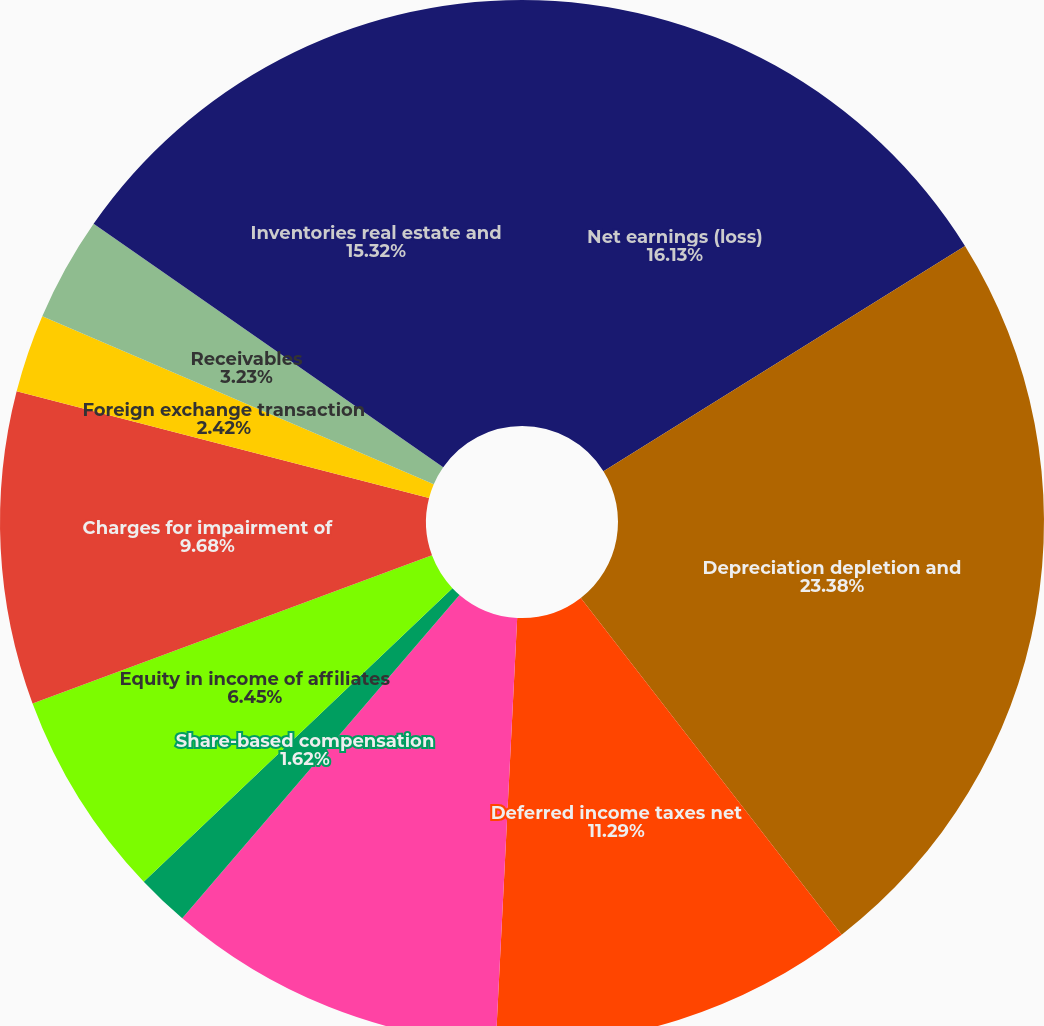Convert chart. <chart><loc_0><loc_0><loc_500><loc_500><pie_chart><fcel>Net earnings (loss)<fcel>Depreciation depletion and<fcel>Deferred income taxes net<fcel>Pension and other<fcel>Share-based compensation<fcel>Equity in income of affiliates<fcel>Charges for impairment of<fcel>Foreign exchange transaction<fcel>Receivables<fcel>Inventories real estate and<nl><fcel>16.13%<fcel>23.38%<fcel>11.29%<fcel>10.48%<fcel>1.62%<fcel>6.45%<fcel>9.68%<fcel>2.42%<fcel>3.23%<fcel>15.32%<nl></chart> 